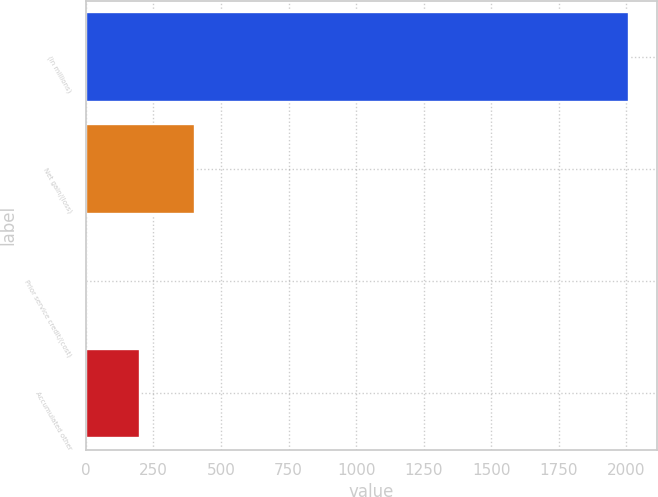Convert chart to OTSL. <chart><loc_0><loc_0><loc_500><loc_500><bar_chart><fcel>(in millions)<fcel>Net gain/(loss)<fcel>Prior service credit/(cost)<fcel>Accumulated other<nl><fcel>2011<fcel>403<fcel>1<fcel>202<nl></chart> 